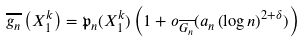<formula> <loc_0><loc_0><loc_500><loc_500>\overline { g _ { n } } \left ( X _ { 1 } ^ { k } \right ) = \mathfrak { p } _ { n } ( X _ { 1 } ^ { k } ) \left ( 1 + o _ { \overline { G _ { n } } } ( a _ { n } \left ( \log n \right ) ^ { 2 + \delta } ) \right )</formula> 